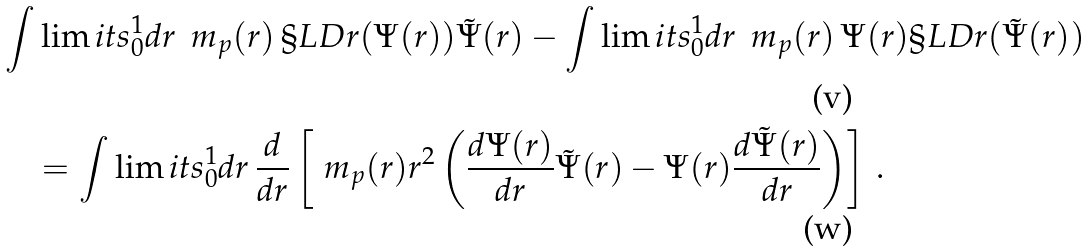<formula> <loc_0><loc_0><loc_500><loc_500>& \int \lim i t s _ { 0 } ^ { 1 } d r \, \ m _ { p } ( r ) \, \S L D r ( \Psi ( r ) ) \tilde { \Psi } ( r ) - \int \lim i t s _ { 0 } ^ { 1 } d r \, \ m _ { p } ( r ) \, \Psi ( r ) \S L D r ( \tilde { \Psi } ( r ) ) \\ & \quad = \int \lim i t s _ { 0 } ^ { 1 } d r \, \frac { d } { d r } \left [ \ m _ { p } ( r ) r ^ { 2 } \left ( \frac { d \Psi ( r ) } { d r } \tilde { \Psi } ( r ) - \Psi ( r ) \frac { d \tilde { \Psi } ( r ) } { d r } \right ) \right ] \, .</formula> 